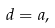<formula> <loc_0><loc_0><loc_500><loc_500>d = a ,</formula> 